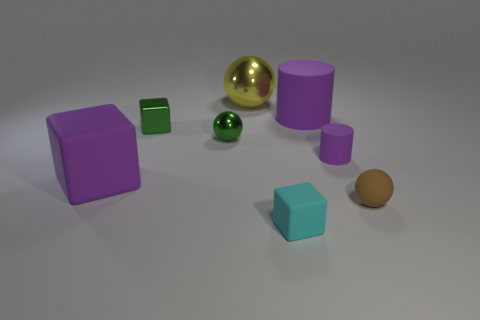What is the size of the matte block that is the same color as the small matte cylinder?
Provide a succinct answer. Large. Are there more cylinders to the left of the metal block than big red rubber cubes?
Keep it short and to the point. No. What is the shape of the cyan thing that is the same material as the small purple object?
Your answer should be very brief. Cube. There is a matte cube in front of the brown ball; is it the same size as the tiny purple thing?
Give a very brief answer. Yes. What shape is the purple object that is left of the big matte thing to the right of the tiny matte cube?
Provide a succinct answer. Cube. There is a matte cube that is left of the matte cube on the right side of the yellow metallic thing; what is its size?
Give a very brief answer. Large. The tiny ball that is to the right of the small cyan thing is what color?
Your answer should be compact. Brown. What size is the brown sphere that is made of the same material as the purple block?
Your answer should be compact. Small. How many tiny brown rubber objects are the same shape as the large metal object?
Your answer should be very brief. 1. What material is the purple object that is the same size as the rubber ball?
Provide a succinct answer. Rubber. 